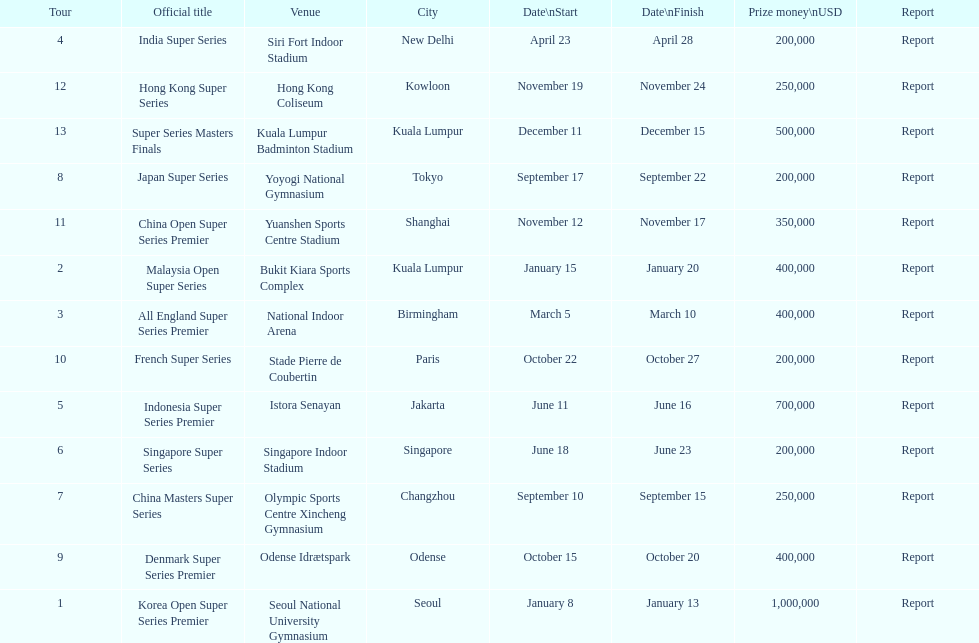Do the winnings for the malaysia open super series exceed or fall short of the french super series? More. 